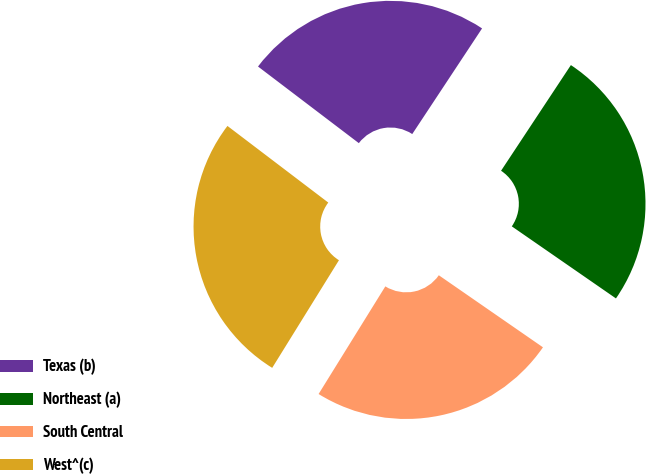<chart> <loc_0><loc_0><loc_500><loc_500><pie_chart><fcel>Texas (b)<fcel>Northeast (a)<fcel>South Central<fcel>West^(c)<nl><fcel>23.95%<fcel>25.34%<fcel>24.2%<fcel>26.51%<nl></chart> 